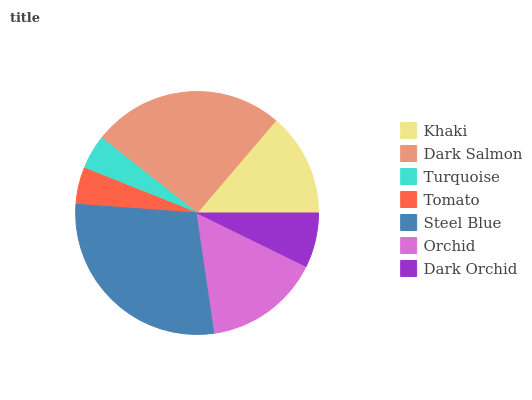Is Turquoise the minimum?
Answer yes or no. Yes. Is Steel Blue the maximum?
Answer yes or no. Yes. Is Dark Salmon the minimum?
Answer yes or no. No. Is Dark Salmon the maximum?
Answer yes or no. No. Is Dark Salmon greater than Khaki?
Answer yes or no. Yes. Is Khaki less than Dark Salmon?
Answer yes or no. Yes. Is Khaki greater than Dark Salmon?
Answer yes or no. No. Is Dark Salmon less than Khaki?
Answer yes or no. No. Is Khaki the high median?
Answer yes or no. Yes. Is Khaki the low median?
Answer yes or no. Yes. Is Dark Salmon the high median?
Answer yes or no. No. Is Tomato the low median?
Answer yes or no. No. 